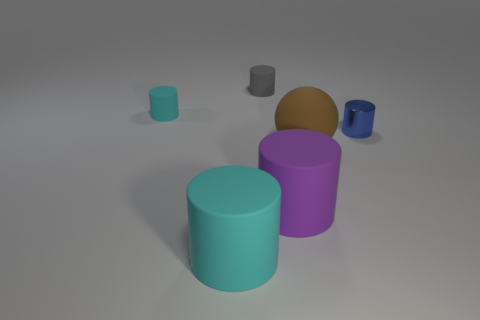Add 1 small purple rubber balls. How many objects exist? 7 Subtract all cyan cylinders. How many cylinders are left? 3 Subtract all big cyan rubber cylinders. How many cylinders are left? 4 Subtract all yellow cylinders. Subtract all yellow blocks. How many cylinders are left? 5 Subtract all cylinders. How many objects are left? 1 Subtract 1 blue cylinders. How many objects are left? 5 Subtract all big matte spheres. Subtract all blue metallic things. How many objects are left? 4 Add 5 small things. How many small things are left? 8 Add 4 big gray metallic cylinders. How many big gray metallic cylinders exist? 4 